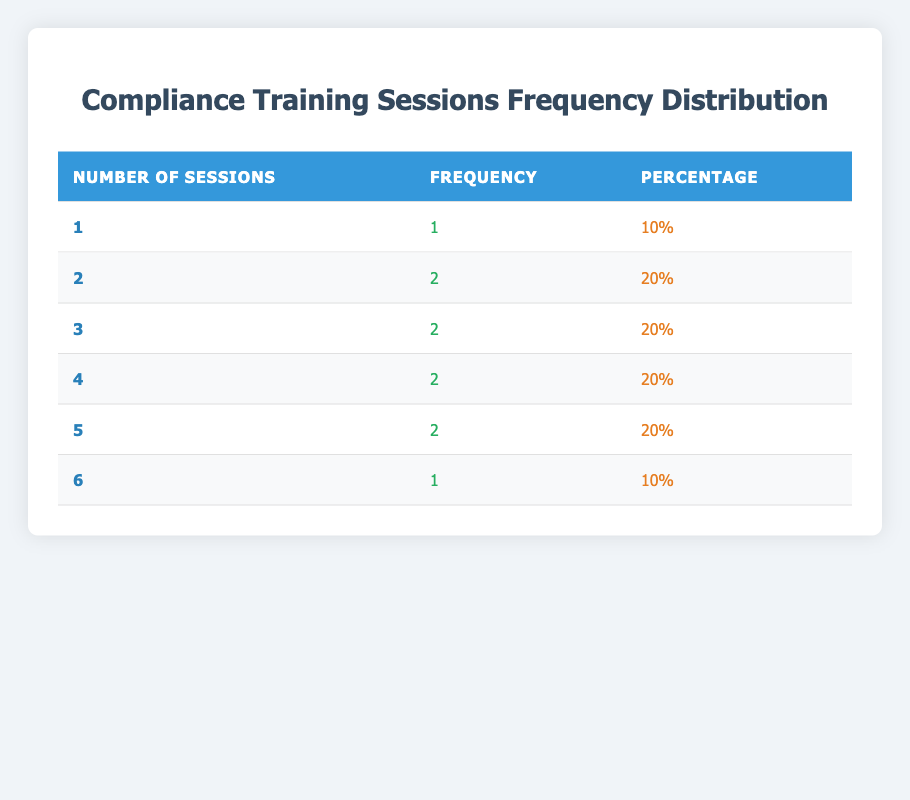What is the frequency of financial advisors who attended 4 sessions? From the table, the frequency for 4 sessions is listed directly as 2.
Answer: 2 How many financial advisors attended only 1 session? The table shows that only 1 financial advisor attended 1 session, which is David Wilson.
Answer: 1 What is the percentage of advisors who attended 5 sessions? The table indicates that 2 financial advisors attended 5 sessions out of a total of 10. Thus, the percentage is (2/10) * 100 = 20%.
Answer: 20% What is the total number of financial advisors who attended more than 3 sessions? By examining the table, we find that 5 advisors attended more than 3 sessions (Emily Johnson, Jessica Davis, James Garcia, Sarah Miller).
Answer: 5 Is there an advisor who attended exactly 6 sessions? The table shows that Sarah Miller is the only advisor who attended exactly 6 sessions. Therefore, the answer is yes.
Answer: Yes What is the average number of sessions attended by financial advisors? To find the average, we need to sum up the sessions attended (2 + 5 + 3 + 4 + 1 + 6 + 5 + 3 + 2 + 4 = 35) and divide by the number of advisors (10). Thus, the average is 35/10 = 3.5.
Answer: 3.5 Which session attendance has the lowest frequency? The lowest frequency corresponds to 1 session, which has a frequency of 1 as per the table.
Answer: 1 session What is the difference between the frequency of advisors who attended 3 sessions and those who attended 2 sessions? The frequency for 3 sessions is 2, while for 2 sessions it is also 2. Therefore, the difference is 2 - 2 = 0.
Answer: 0 